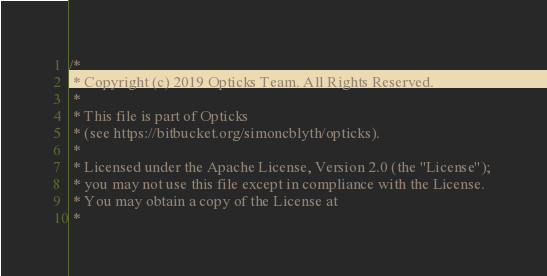<code> <loc_0><loc_0><loc_500><loc_500><_C_>/*
 * Copyright (c) 2019 Opticks Team. All Rights Reserved.
 *
 * This file is part of Opticks
 * (see https://bitbucket.org/simoncblyth/opticks).
 *
 * Licensed under the Apache License, Version 2.0 (the "License"); 
 * you may not use this file except in compliance with the License.  
 * You may obtain a copy of the License at
 *</code> 